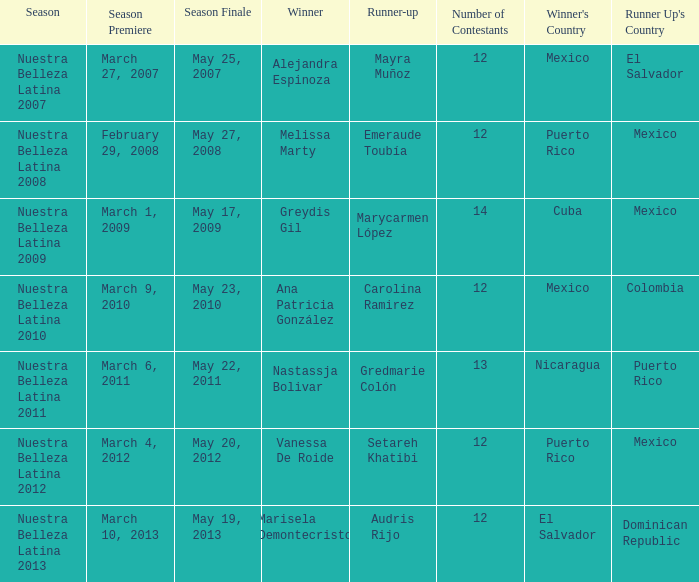Parse the full table. {'header': ['Season', 'Season Premiere', 'Season Finale', 'Winner', 'Runner-up', 'Number of Contestants', "Winner's Country", "Runner Up's Country"], 'rows': [['Nuestra Belleza Latina 2007', 'March 27, 2007', 'May 25, 2007', 'Alejandra Espinoza', 'Mayra Muñoz', '12', 'Mexico', 'El Salvador'], ['Nuestra Belleza Latina 2008', 'February 29, 2008', 'May 27, 2008', 'Melissa Marty', 'Emeraude Toubía', '12', 'Puerto Rico', 'Mexico'], ['Nuestra Belleza Latina 2009', 'March 1, 2009', 'May 17, 2009', 'Greydis Gil', 'Marycarmen López', '14', 'Cuba', 'Mexico'], ['Nuestra Belleza Latina 2010', 'March 9, 2010', 'May 23, 2010', 'Ana Patricia González', 'Carolina Ramirez', '12', 'Mexico', 'Colombia'], ['Nuestra Belleza Latina 2011', 'March 6, 2011', 'May 22, 2011', 'Nastassja Bolivar', 'Gredmarie Colón', '13', 'Nicaragua', 'Puerto Rico'], ['Nuestra Belleza Latina 2012', 'March 4, 2012', 'May 20, 2012', 'Vanessa De Roide', 'Setareh Khatibi', '12', 'Puerto Rico', 'Mexico'], ['Nuestra Belleza Latina 2013', 'March 10, 2013', 'May 19, 2013', 'Marisela Demontecristo', 'Audris Rijo', '12', 'El Salvador', 'Dominican Republic']]} What season had more than 12 contestants in which greydis gil won? Nuestra Belleza Latina 2009. 